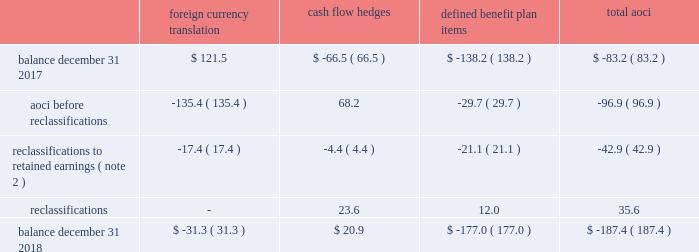Zimmer biomet holdings , inc .
And subsidiaries 2018 form 10-k annual report notes to consolidated financial statements ( continued ) default for unsecured financing arrangements , including , among other things , limitations on consolidations , mergers and sales of assets .
Financial covenants under the 2018 , 2016 and 2014 credit agreements include a consolidated indebtedness to consolidated ebitda ratio of no greater than 5.0 to 1.0 through june 30 , 2017 , and no greater than 4.5 to 1.0 thereafter .
If our credit rating falls below investment grade , additional restrictions would result , including restrictions on investments and payment of dividends .
We were in compliance with all covenants under the 2018 , 2016 and 2014 credit agreements as of december 31 , 2018 .
As of december 31 , 2018 , there were no borrowings outstanding under the multicurrency revolving facility .
We may , at our option , redeem our senior notes , in whole or in part , at any time upon payment of the principal , any applicable make-whole premium , and accrued and unpaid interest to the date of redemption , except that the floating rate notes due 2021 may not be redeemed until on or after march 20 , 2019 and such notes do not have any applicable make-whole premium .
In addition , we may redeem , at our option , the 2.700% ( 2.700 % ) senior notes due 2020 , the 3.375% ( 3.375 % ) senior notes due 2021 , the 3.150% ( 3.150 % ) senior notes due 2022 , the 3.700% ( 3.700 % ) senior notes due 2023 , the 3.550% ( 3.550 % ) senior notes due 2025 , the 4.250% ( 4.250 % ) senior notes due 2035 and the 4.450% ( 4.450 % ) senior notes due 2045 without any make-whole premium at specified dates ranging from one month to six months in advance of the scheduled maturity date .
The estimated fair value of our senior notes as of december 31 , 2018 , based on quoted prices for the specific securities from transactions in over-the-counter markets ( level 2 ) , was $ 7798.9 million .
The estimated fair value of japan term loan a and japan term loan b , in the aggregate , as of december 31 , 2018 , based upon publicly available market yield curves and the terms of the debt ( level 2 ) , was $ 294.7 million .
The carrying values of u.s .
Term loan b and u.s .
Term loan c approximate fair value as they bear interest at short-term variable market rates .
We entered into interest rate swap agreements which we designated as fair value hedges of underlying fixed-rate obligations on our senior notes due 2019 and 2021 .
These fair value hedges were settled in 2016 .
In 2016 , we entered into various variable-to-fixed interest rate swap agreements that were accounted for as cash flow hedges of u.s .
Term loan b .
In 2018 , we entered into cross-currency interest rate swaps that we designated as net investment hedges .
The excluded component of these net investment hedges is recorded in interest expense , net .
See note 13 for additional information regarding our interest rate swap agreements .
We also have available uncommitted credit facilities totaling $ 55.0 million .
At december 31 , 2018 and 2017 , the weighted average interest rate for our borrowings was 3.1 percent and 2.9 percent , respectively .
We paid $ 282.8 million , $ 317.5 million , and $ 363.1 million in interest during 2018 , 2017 , and 2016 , respectively .
12 .
Accumulated other comprehensive ( loss ) income aoci refers to certain gains and losses that under gaap are included in comprehensive income but are excluded from net earnings as these amounts are initially recorded as an adjustment to stockholders 2019 equity .
Amounts in aoci may be reclassified to net earnings upon the occurrence of certain events .
Our aoci is comprised of foreign currency translation adjustments , including unrealized gains and losses on net investment hedges , unrealized gains and losses on cash flow hedges , and amortization of prior service costs and unrecognized gains and losses in actuarial assumptions on our defined benefit plans .
Foreign currency translation adjustments are reclassified to net earnings upon sale or upon a complete or substantially complete liquidation of an investment in a foreign entity .
Unrealized gains and losses on cash flow hedges are reclassified to net earnings when the hedged item affects net earnings .
Amounts related to defined benefit plans that are in aoci are reclassified over the service periods of employees in the plan .
See note 14 for more information on our defined benefit plans .
The table shows the changes in the components of aoci , net of tax ( in millions ) : foreign currency translation hedges defined benefit plan items .

What percentage of aoci at december 31 , 2018 is attributed to defined benefit plan items? 
Computations: (-177.0 / -187.4)
Answer: 0.9445. 